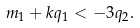Convert formula to latex. <formula><loc_0><loc_0><loc_500><loc_500>m _ { 1 } + k q _ { 1 } < - 3 q _ { 2 } .</formula> 